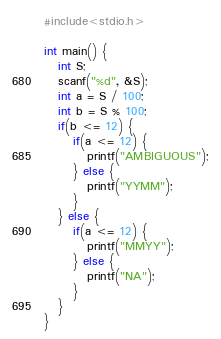Convert code to text. <code><loc_0><loc_0><loc_500><loc_500><_C_>#include<stdio.h>

int main() {
   int S;
   scanf("%d", &S);
   int a = S / 100;
   int b = S % 100;
   if(b <= 12) {
      if(a <= 12) {
         printf("AMBIGUOUS");
      } else {
         printf("YYMM");
      }
   } else {
      if(a <= 12) {
         printf("MMYY");
      } else {
         printf("NA");
      }
   }
}
</code> 